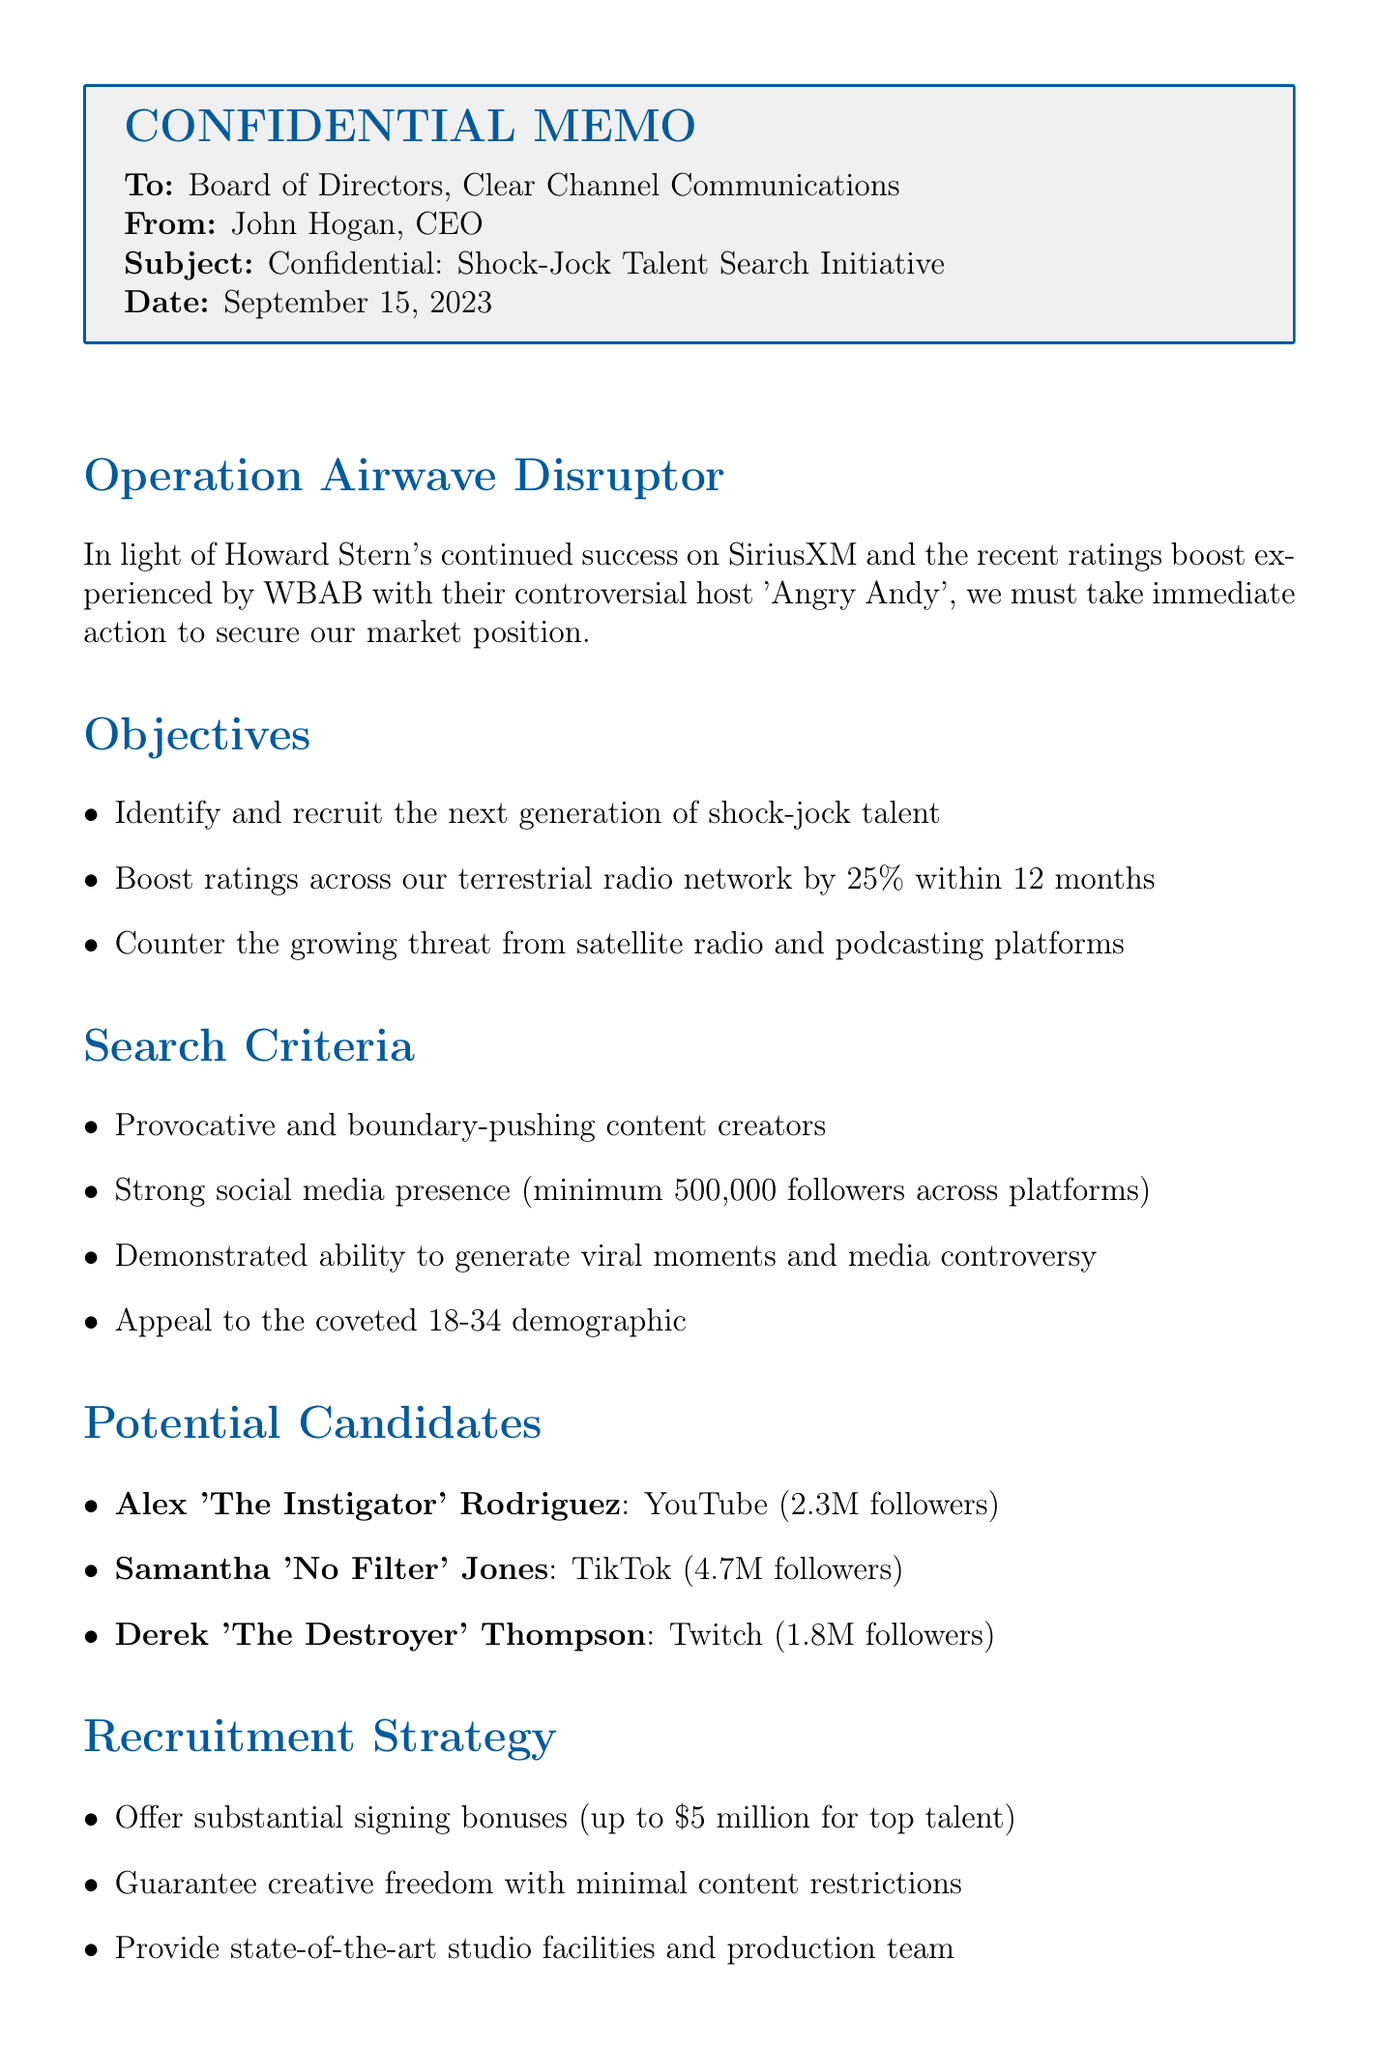What is the name of the initiative? The initiative is named "Operation Airwave Disruptor."
Answer: Operation Airwave Disruptor Who is the memo addressed to? The memo is addressed to the "Board of Directors, Clear Channel Communications."
Answer: Board of Directors, Clear Channel Communications What is the target increase in ratings within 12 months? The target increase in ratings is 25%.
Answer: 25% How many followers must candidates have on social media? Candidates must have a minimum of 500,000 followers across platforms.
Answer: 500,000 What is one notable controversy associated with Samantha 'No Filter' Jones? Samantha 'No Filter' Jones had a public feud with multiple A-list celebrities.
Answer: Public feud with multiple A-list celebrities What phase involves contract negotiations? Contract negotiations occur during Phase 2.
Answer: Phase 2 What is the total budget allocation for talent acquisition? The total budget allocation for talent acquisition is $20 million.
Answer: $20 million What is the first phase of the timeline? The first phase is talent identification and initial outreach.
Answer: Talent identification and initial outreach 